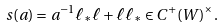<formula> <loc_0><loc_0><loc_500><loc_500>s ( a ) = a ^ { - 1 } \ell _ { * } \ell + \ell \ell _ { * } \in C ^ { + } ( W ) ^ { \times } .</formula> 